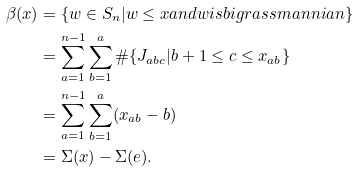<formula> <loc_0><loc_0><loc_500><loc_500>\beta ( x ) & = \{ w \in S _ { n } | w \leq x a n d w i s b i g r a s s m a n n i a n \} \\ & = \sum _ { a = 1 } ^ { n - 1 } \sum _ { b = 1 } ^ { a } \# \{ J _ { a b c } | b + 1 \leq c \leq x _ { a b } \} \\ & = \sum _ { a = 1 } ^ { n - 1 } \sum _ { b = 1 } ^ { a } ( x _ { a b } - b ) \\ & = \Sigma ( x ) - \Sigma ( e ) .</formula> 